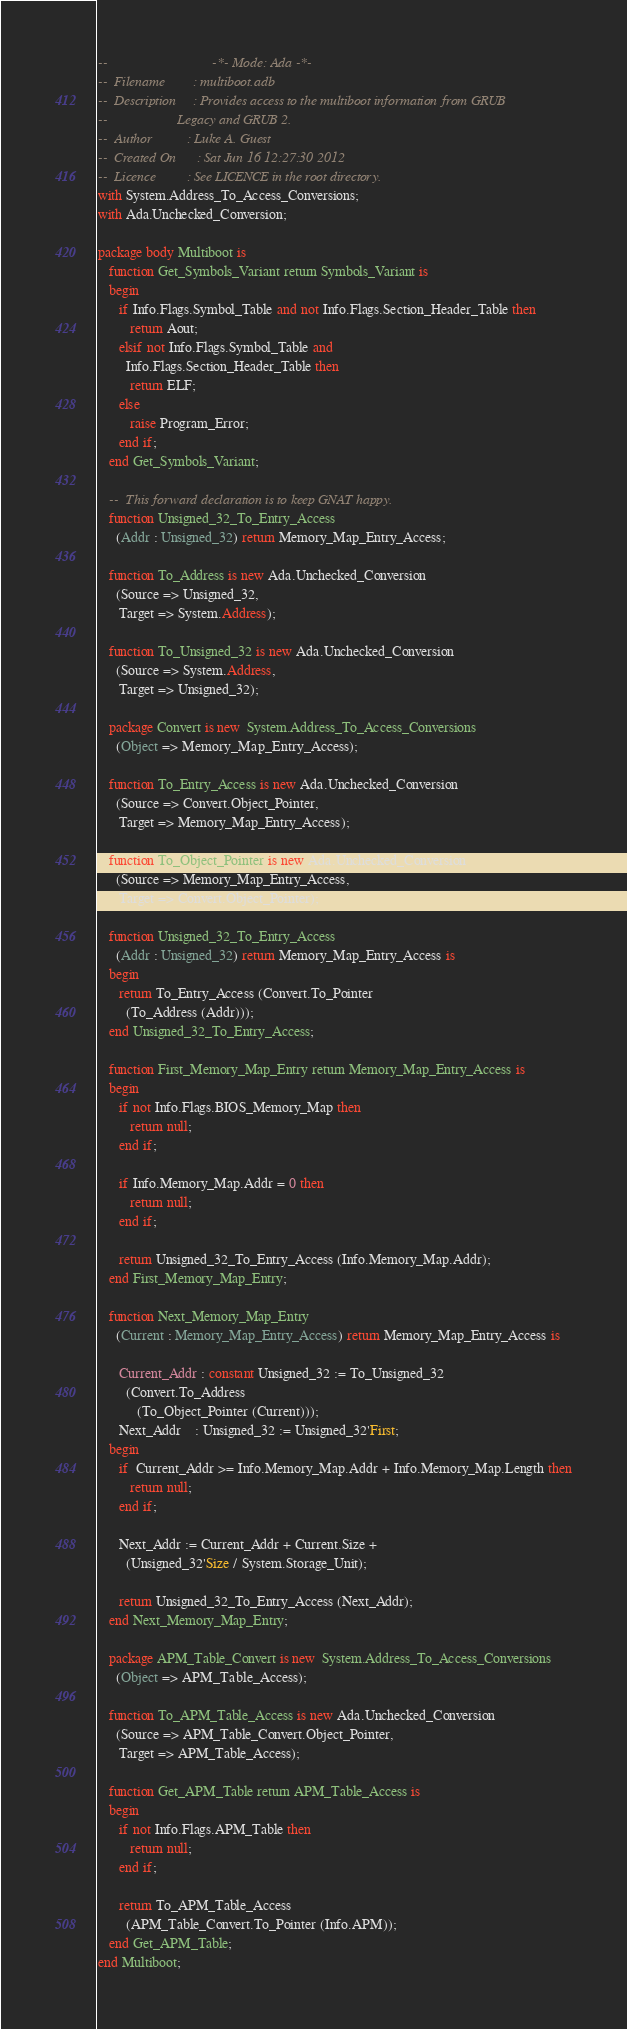Convert code to text. <code><loc_0><loc_0><loc_500><loc_500><_Ada_>--                              -*- Mode: Ada -*-
--  Filename        : multiboot.adb
--  Description     : Provides access to the multiboot information from GRUB
--                    Legacy and GRUB 2.
--  Author          : Luke A. Guest
--  Created On      : Sat Jun 16 12:27:30 2012
--  Licence         : See LICENCE in the root directory.
with System.Address_To_Access_Conversions;
with Ada.Unchecked_Conversion;

package body Multiboot is
   function Get_Symbols_Variant return Symbols_Variant is
   begin
      if Info.Flags.Symbol_Table and not Info.Flags.Section_Header_Table then
         return Aout;
      elsif not Info.Flags.Symbol_Table and
        Info.Flags.Section_Header_Table then
         return ELF;
      else
         raise Program_Error;
      end if;
   end Get_Symbols_Variant;

   --  This forward declaration is to keep GNAT happy.
   function Unsigned_32_To_Entry_Access
     (Addr : Unsigned_32) return Memory_Map_Entry_Access;

   function To_Address is new Ada.Unchecked_Conversion
     (Source => Unsigned_32,
      Target => System.Address);

   function To_Unsigned_32 is new Ada.Unchecked_Conversion
     (Source => System.Address,
      Target => Unsigned_32);

   package Convert is new  System.Address_To_Access_Conversions
     (Object => Memory_Map_Entry_Access);

   function To_Entry_Access is new Ada.Unchecked_Conversion
     (Source => Convert.Object_Pointer,
      Target => Memory_Map_Entry_Access);

   function To_Object_Pointer is new Ada.Unchecked_Conversion
     (Source => Memory_Map_Entry_Access,
      Target => Convert.Object_Pointer);

   function Unsigned_32_To_Entry_Access
     (Addr : Unsigned_32) return Memory_Map_Entry_Access is
   begin
      return To_Entry_Access (Convert.To_Pointer
        (To_Address (Addr)));
   end Unsigned_32_To_Entry_Access;

   function First_Memory_Map_Entry return Memory_Map_Entry_Access is
   begin
      if not Info.Flags.BIOS_Memory_Map then
         return null;
      end if;

      if Info.Memory_Map.Addr = 0 then
         return null;
      end if;

      return Unsigned_32_To_Entry_Access (Info.Memory_Map.Addr);
   end First_Memory_Map_Entry;

   function Next_Memory_Map_Entry
     (Current : Memory_Map_Entry_Access) return Memory_Map_Entry_Access is

      Current_Addr : constant Unsigned_32 := To_Unsigned_32
        (Convert.To_Address
           (To_Object_Pointer (Current)));
      Next_Addr    : Unsigned_32 := Unsigned_32'First;
   begin
      if  Current_Addr >= Info.Memory_Map.Addr + Info.Memory_Map.Length then
         return null;
      end if;

      Next_Addr := Current_Addr + Current.Size +
        (Unsigned_32'Size / System.Storage_Unit);

      return Unsigned_32_To_Entry_Access (Next_Addr);
   end Next_Memory_Map_Entry;

   package APM_Table_Convert is new  System.Address_To_Access_Conversions
     (Object => APM_Table_Access);

   function To_APM_Table_Access is new Ada.Unchecked_Conversion
     (Source => APM_Table_Convert.Object_Pointer,
      Target => APM_Table_Access);

   function Get_APM_Table return APM_Table_Access is
   begin
      if not Info.Flags.APM_Table then
         return null;
      end if;

      return To_APM_Table_Access
        (APM_Table_Convert.To_Pointer (Info.APM));
   end Get_APM_Table;
end Multiboot;
</code> 